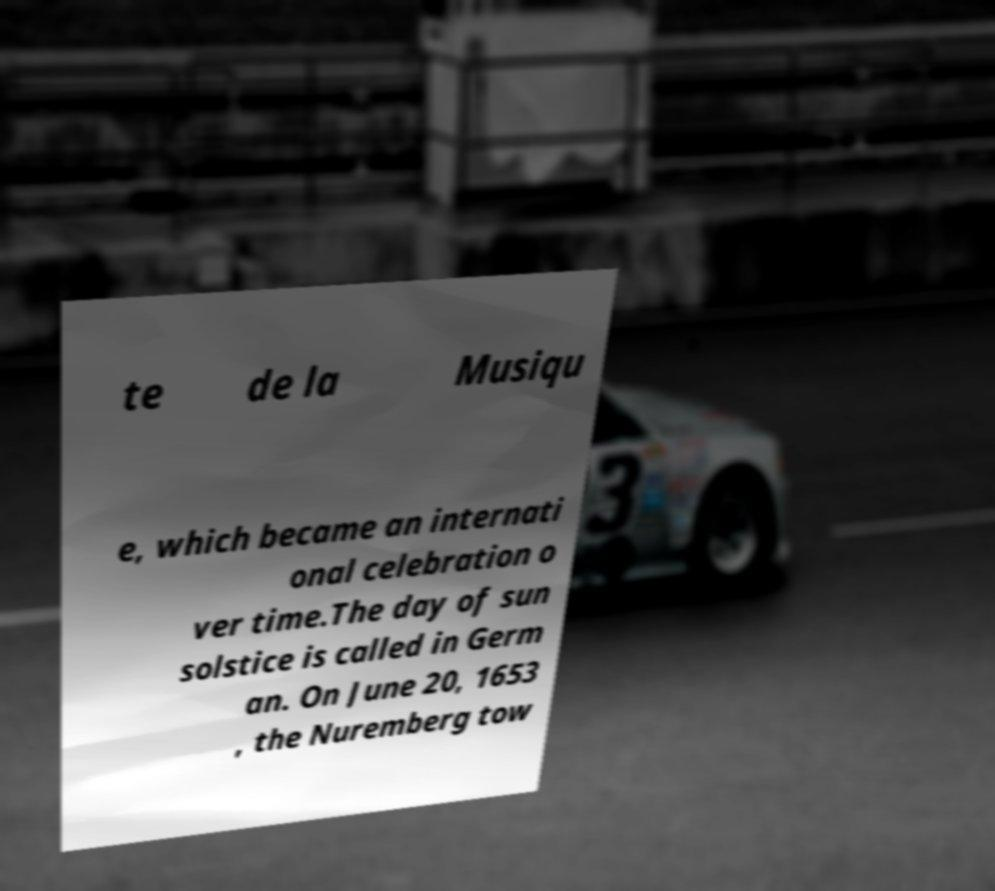Please read and relay the text visible in this image. What does it say? te de la Musiqu e, which became an internati onal celebration o ver time.The day of sun solstice is called in Germ an. On June 20, 1653 , the Nuremberg tow 